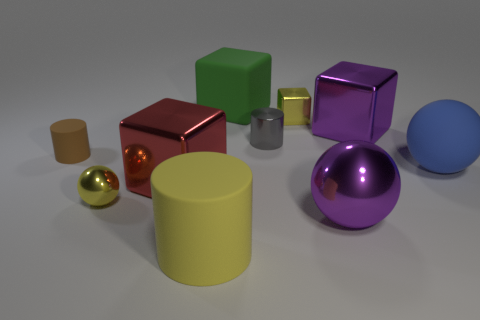Are there any other things of the same color as the tiny metallic sphere? Yes, the small sphere appears to share a similar color with the larger sphere next to it. The similarities in their reflective metallic surfaces suggest they could be made of the same material or have the same finishing process, resulting in the golden color and shiny appearance. 